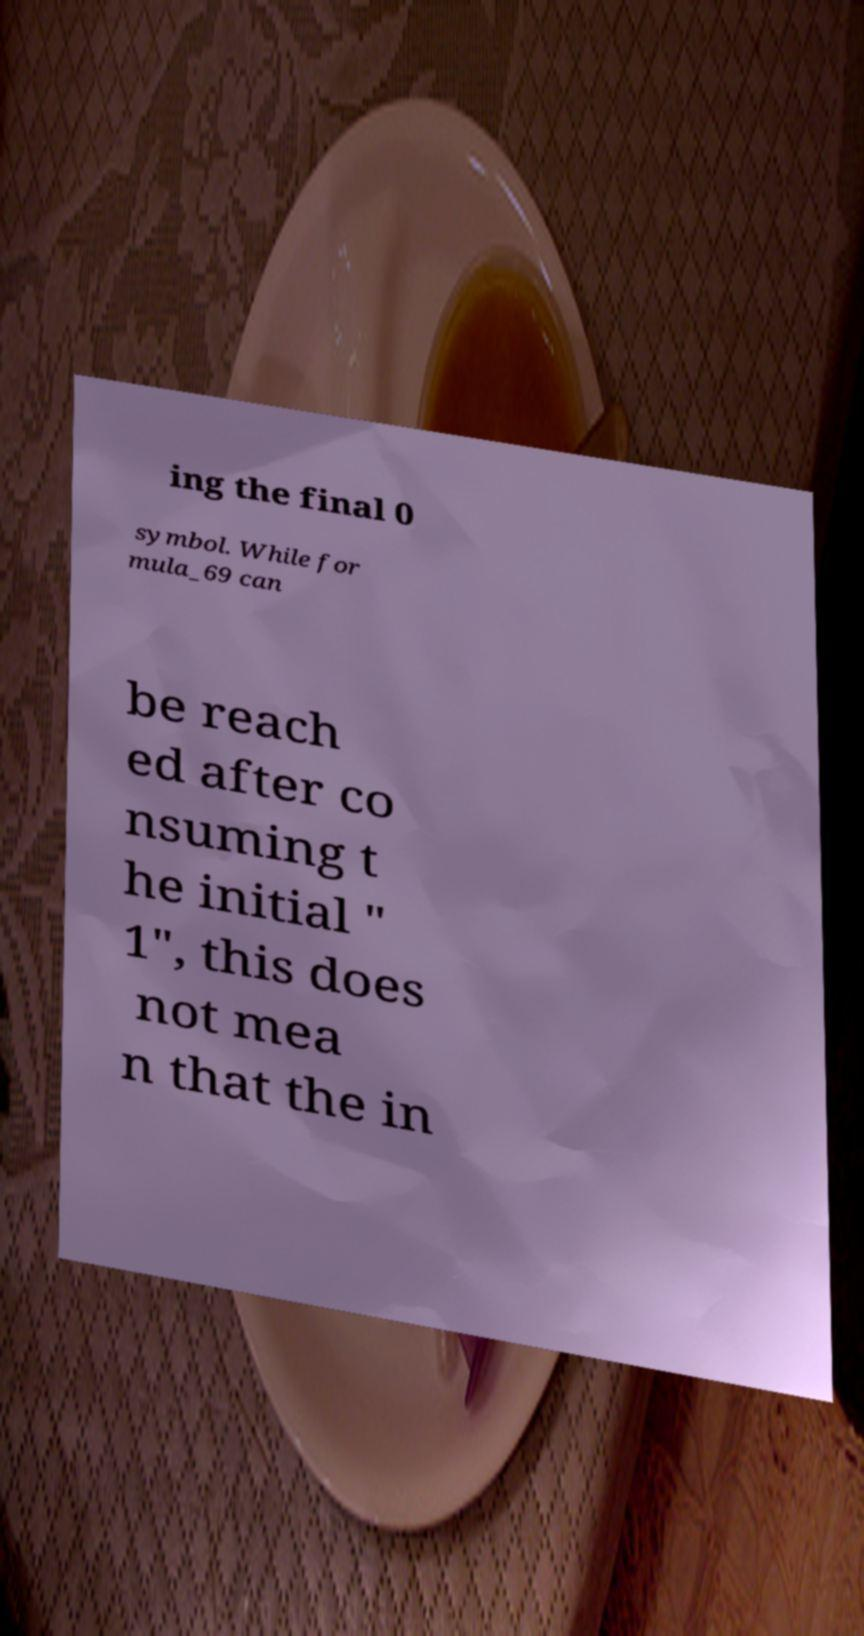Could you assist in decoding the text presented in this image and type it out clearly? ing the final 0 symbol. While for mula_69 can be reach ed after co nsuming t he initial " 1", this does not mea n that the in 